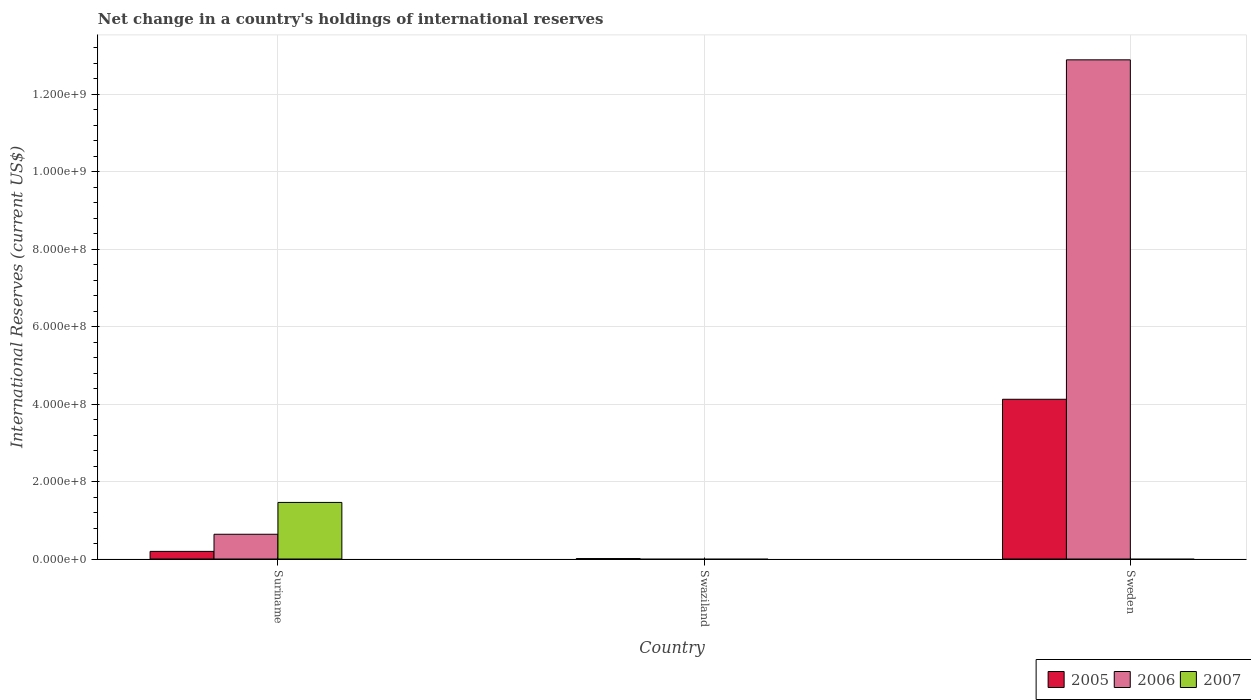Are the number of bars per tick equal to the number of legend labels?
Ensure brevity in your answer.  No. How many bars are there on the 1st tick from the left?
Your response must be concise. 3. How many bars are there on the 3rd tick from the right?
Your answer should be very brief. 3. What is the label of the 3rd group of bars from the left?
Provide a short and direct response. Sweden. What is the international reserves in 2006 in Swaziland?
Provide a succinct answer. 0. Across all countries, what is the maximum international reserves in 2007?
Your response must be concise. 1.46e+08. What is the total international reserves in 2006 in the graph?
Ensure brevity in your answer.  1.35e+09. What is the difference between the international reserves in 2005 in Swaziland and that in Sweden?
Your answer should be compact. -4.11e+08. What is the difference between the international reserves in 2007 in Suriname and the international reserves in 2006 in Swaziland?
Your answer should be compact. 1.46e+08. What is the average international reserves in 2006 per country?
Offer a terse response. 4.51e+08. What is the difference between the international reserves of/in 2005 and international reserves of/in 2006 in Sweden?
Keep it short and to the point. -8.76e+08. What is the ratio of the international reserves in 2005 in Swaziland to that in Sweden?
Your answer should be very brief. 0. What is the difference between the highest and the second highest international reserves in 2005?
Your answer should be very brief. -4.11e+08. What is the difference between the highest and the lowest international reserves in 2006?
Your answer should be very brief. 1.29e+09. In how many countries, is the international reserves in 2007 greater than the average international reserves in 2007 taken over all countries?
Provide a succinct answer. 1. Is the sum of the international reserves in 2005 in Swaziland and Sweden greater than the maximum international reserves in 2006 across all countries?
Make the answer very short. No. How many bars are there?
Provide a short and direct response. 6. Are the values on the major ticks of Y-axis written in scientific E-notation?
Your response must be concise. Yes. Does the graph contain any zero values?
Provide a succinct answer. Yes. Does the graph contain grids?
Give a very brief answer. Yes. Where does the legend appear in the graph?
Keep it short and to the point. Bottom right. How many legend labels are there?
Your response must be concise. 3. What is the title of the graph?
Your response must be concise. Net change in a country's holdings of international reserves. What is the label or title of the Y-axis?
Your answer should be compact. International Reserves (current US$). What is the International Reserves (current US$) in 2005 in Suriname?
Provide a succinct answer. 1.97e+07. What is the International Reserves (current US$) of 2006 in Suriname?
Keep it short and to the point. 6.39e+07. What is the International Reserves (current US$) of 2007 in Suriname?
Your response must be concise. 1.46e+08. What is the International Reserves (current US$) in 2005 in Swaziland?
Make the answer very short. 1.10e+06. What is the International Reserves (current US$) of 2006 in Swaziland?
Ensure brevity in your answer.  0. What is the International Reserves (current US$) of 2007 in Swaziland?
Offer a terse response. 0. What is the International Reserves (current US$) in 2005 in Sweden?
Offer a very short reply. 4.12e+08. What is the International Reserves (current US$) of 2006 in Sweden?
Give a very brief answer. 1.29e+09. Across all countries, what is the maximum International Reserves (current US$) in 2005?
Offer a terse response. 4.12e+08. Across all countries, what is the maximum International Reserves (current US$) of 2006?
Keep it short and to the point. 1.29e+09. Across all countries, what is the maximum International Reserves (current US$) of 2007?
Offer a very short reply. 1.46e+08. Across all countries, what is the minimum International Reserves (current US$) of 2005?
Provide a short and direct response. 1.10e+06. Across all countries, what is the minimum International Reserves (current US$) in 2007?
Your answer should be compact. 0. What is the total International Reserves (current US$) of 2005 in the graph?
Make the answer very short. 4.33e+08. What is the total International Reserves (current US$) in 2006 in the graph?
Ensure brevity in your answer.  1.35e+09. What is the total International Reserves (current US$) in 2007 in the graph?
Provide a succinct answer. 1.46e+08. What is the difference between the International Reserves (current US$) in 2005 in Suriname and that in Swaziland?
Your answer should be compact. 1.86e+07. What is the difference between the International Reserves (current US$) of 2005 in Suriname and that in Sweden?
Provide a succinct answer. -3.93e+08. What is the difference between the International Reserves (current US$) in 2006 in Suriname and that in Sweden?
Ensure brevity in your answer.  -1.22e+09. What is the difference between the International Reserves (current US$) in 2005 in Swaziland and that in Sweden?
Provide a short and direct response. -4.11e+08. What is the difference between the International Reserves (current US$) in 2005 in Suriname and the International Reserves (current US$) in 2006 in Sweden?
Your answer should be very brief. -1.27e+09. What is the difference between the International Reserves (current US$) in 2005 in Swaziland and the International Reserves (current US$) in 2006 in Sweden?
Give a very brief answer. -1.29e+09. What is the average International Reserves (current US$) in 2005 per country?
Offer a terse response. 1.44e+08. What is the average International Reserves (current US$) in 2006 per country?
Provide a short and direct response. 4.51e+08. What is the average International Reserves (current US$) of 2007 per country?
Keep it short and to the point. 4.87e+07. What is the difference between the International Reserves (current US$) in 2005 and International Reserves (current US$) in 2006 in Suriname?
Your response must be concise. -4.42e+07. What is the difference between the International Reserves (current US$) in 2005 and International Reserves (current US$) in 2007 in Suriname?
Ensure brevity in your answer.  -1.26e+08. What is the difference between the International Reserves (current US$) in 2006 and International Reserves (current US$) in 2007 in Suriname?
Offer a terse response. -8.22e+07. What is the difference between the International Reserves (current US$) of 2005 and International Reserves (current US$) of 2006 in Sweden?
Your answer should be compact. -8.76e+08. What is the ratio of the International Reserves (current US$) of 2005 in Suriname to that in Swaziland?
Offer a terse response. 17.84. What is the ratio of the International Reserves (current US$) of 2005 in Suriname to that in Sweden?
Make the answer very short. 0.05. What is the ratio of the International Reserves (current US$) of 2006 in Suriname to that in Sweden?
Provide a succinct answer. 0.05. What is the ratio of the International Reserves (current US$) in 2005 in Swaziland to that in Sweden?
Your response must be concise. 0. What is the difference between the highest and the second highest International Reserves (current US$) of 2005?
Provide a short and direct response. 3.93e+08. What is the difference between the highest and the lowest International Reserves (current US$) in 2005?
Ensure brevity in your answer.  4.11e+08. What is the difference between the highest and the lowest International Reserves (current US$) of 2006?
Ensure brevity in your answer.  1.29e+09. What is the difference between the highest and the lowest International Reserves (current US$) of 2007?
Give a very brief answer. 1.46e+08. 